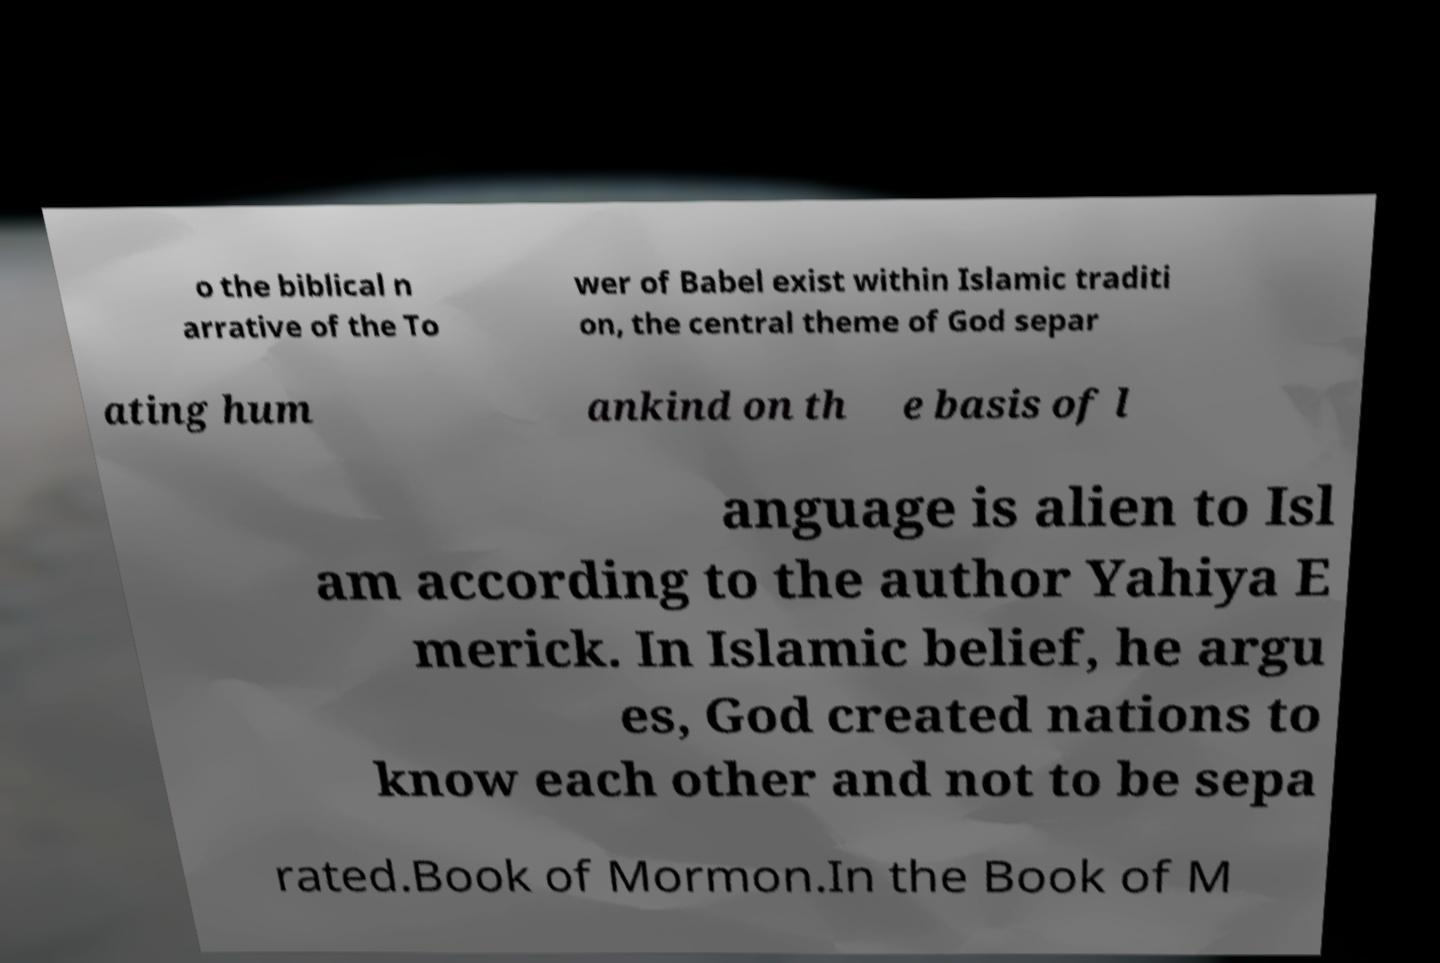Could you extract and type out the text from this image? o the biblical n arrative of the To wer of Babel exist within Islamic traditi on, the central theme of God separ ating hum ankind on th e basis of l anguage is alien to Isl am according to the author Yahiya E merick. In Islamic belief, he argu es, God created nations to know each other and not to be sepa rated.Book of Mormon.In the Book of M 